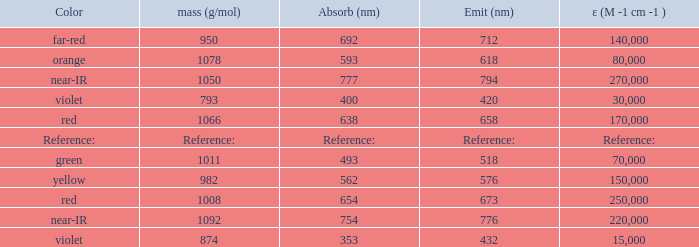What is the Absorbtion (in nanometers) of the color Violet with an emission of 432 nm? 353.0. Would you mind parsing the complete table? {'header': ['Color', 'mass (g/mol)', 'Absorb (nm)', 'Emit (nm)', 'ε (M -1 cm -1 )'], 'rows': [['far-red', '950', '692', '712', '140,000'], ['orange', '1078', '593', '618', '80,000'], ['near-IR', '1050', '777', '794', '270,000'], ['violet', '793', '400', '420', '30,000'], ['red', '1066', '638', '658', '170,000'], ['Reference:', 'Reference:', 'Reference:', 'Reference:', 'Reference:'], ['green', '1011', '493', '518', '70,000'], ['yellow', '982', '562', '576', '150,000'], ['red', '1008', '654', '673', '250,000'], ['near-IR', '1092', '754', '776', '220,000'], ['violet', '874', '353', '432', '15,000']]} 